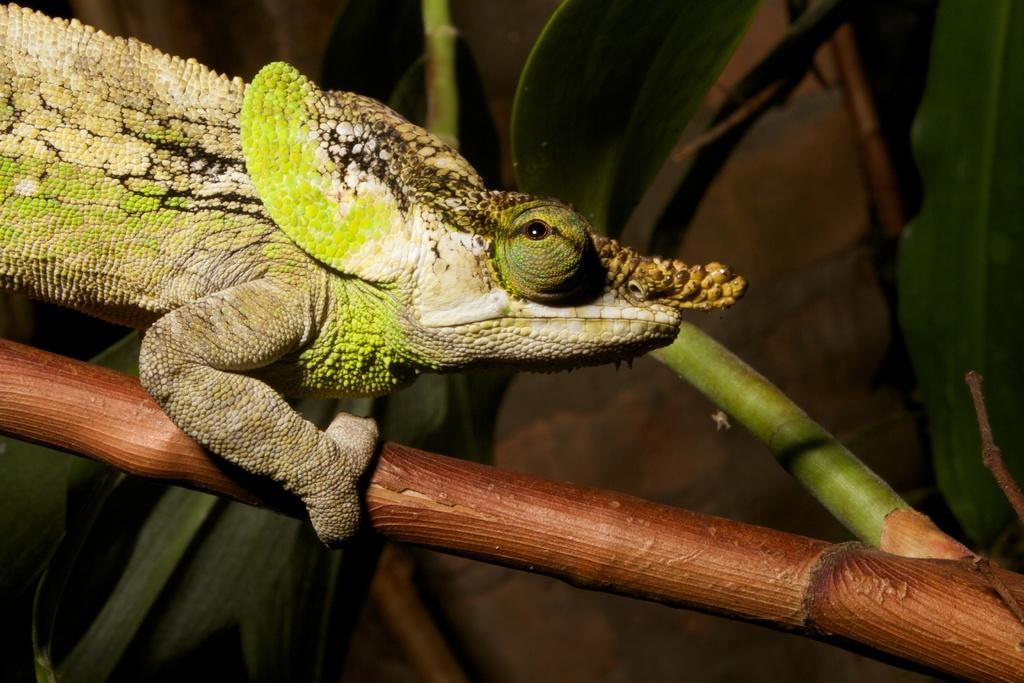How would you summarize this image in a sentence or two? In this image I can see a reptile which is in green,white and black color. It is on the stem. Background is in brown and green color. 